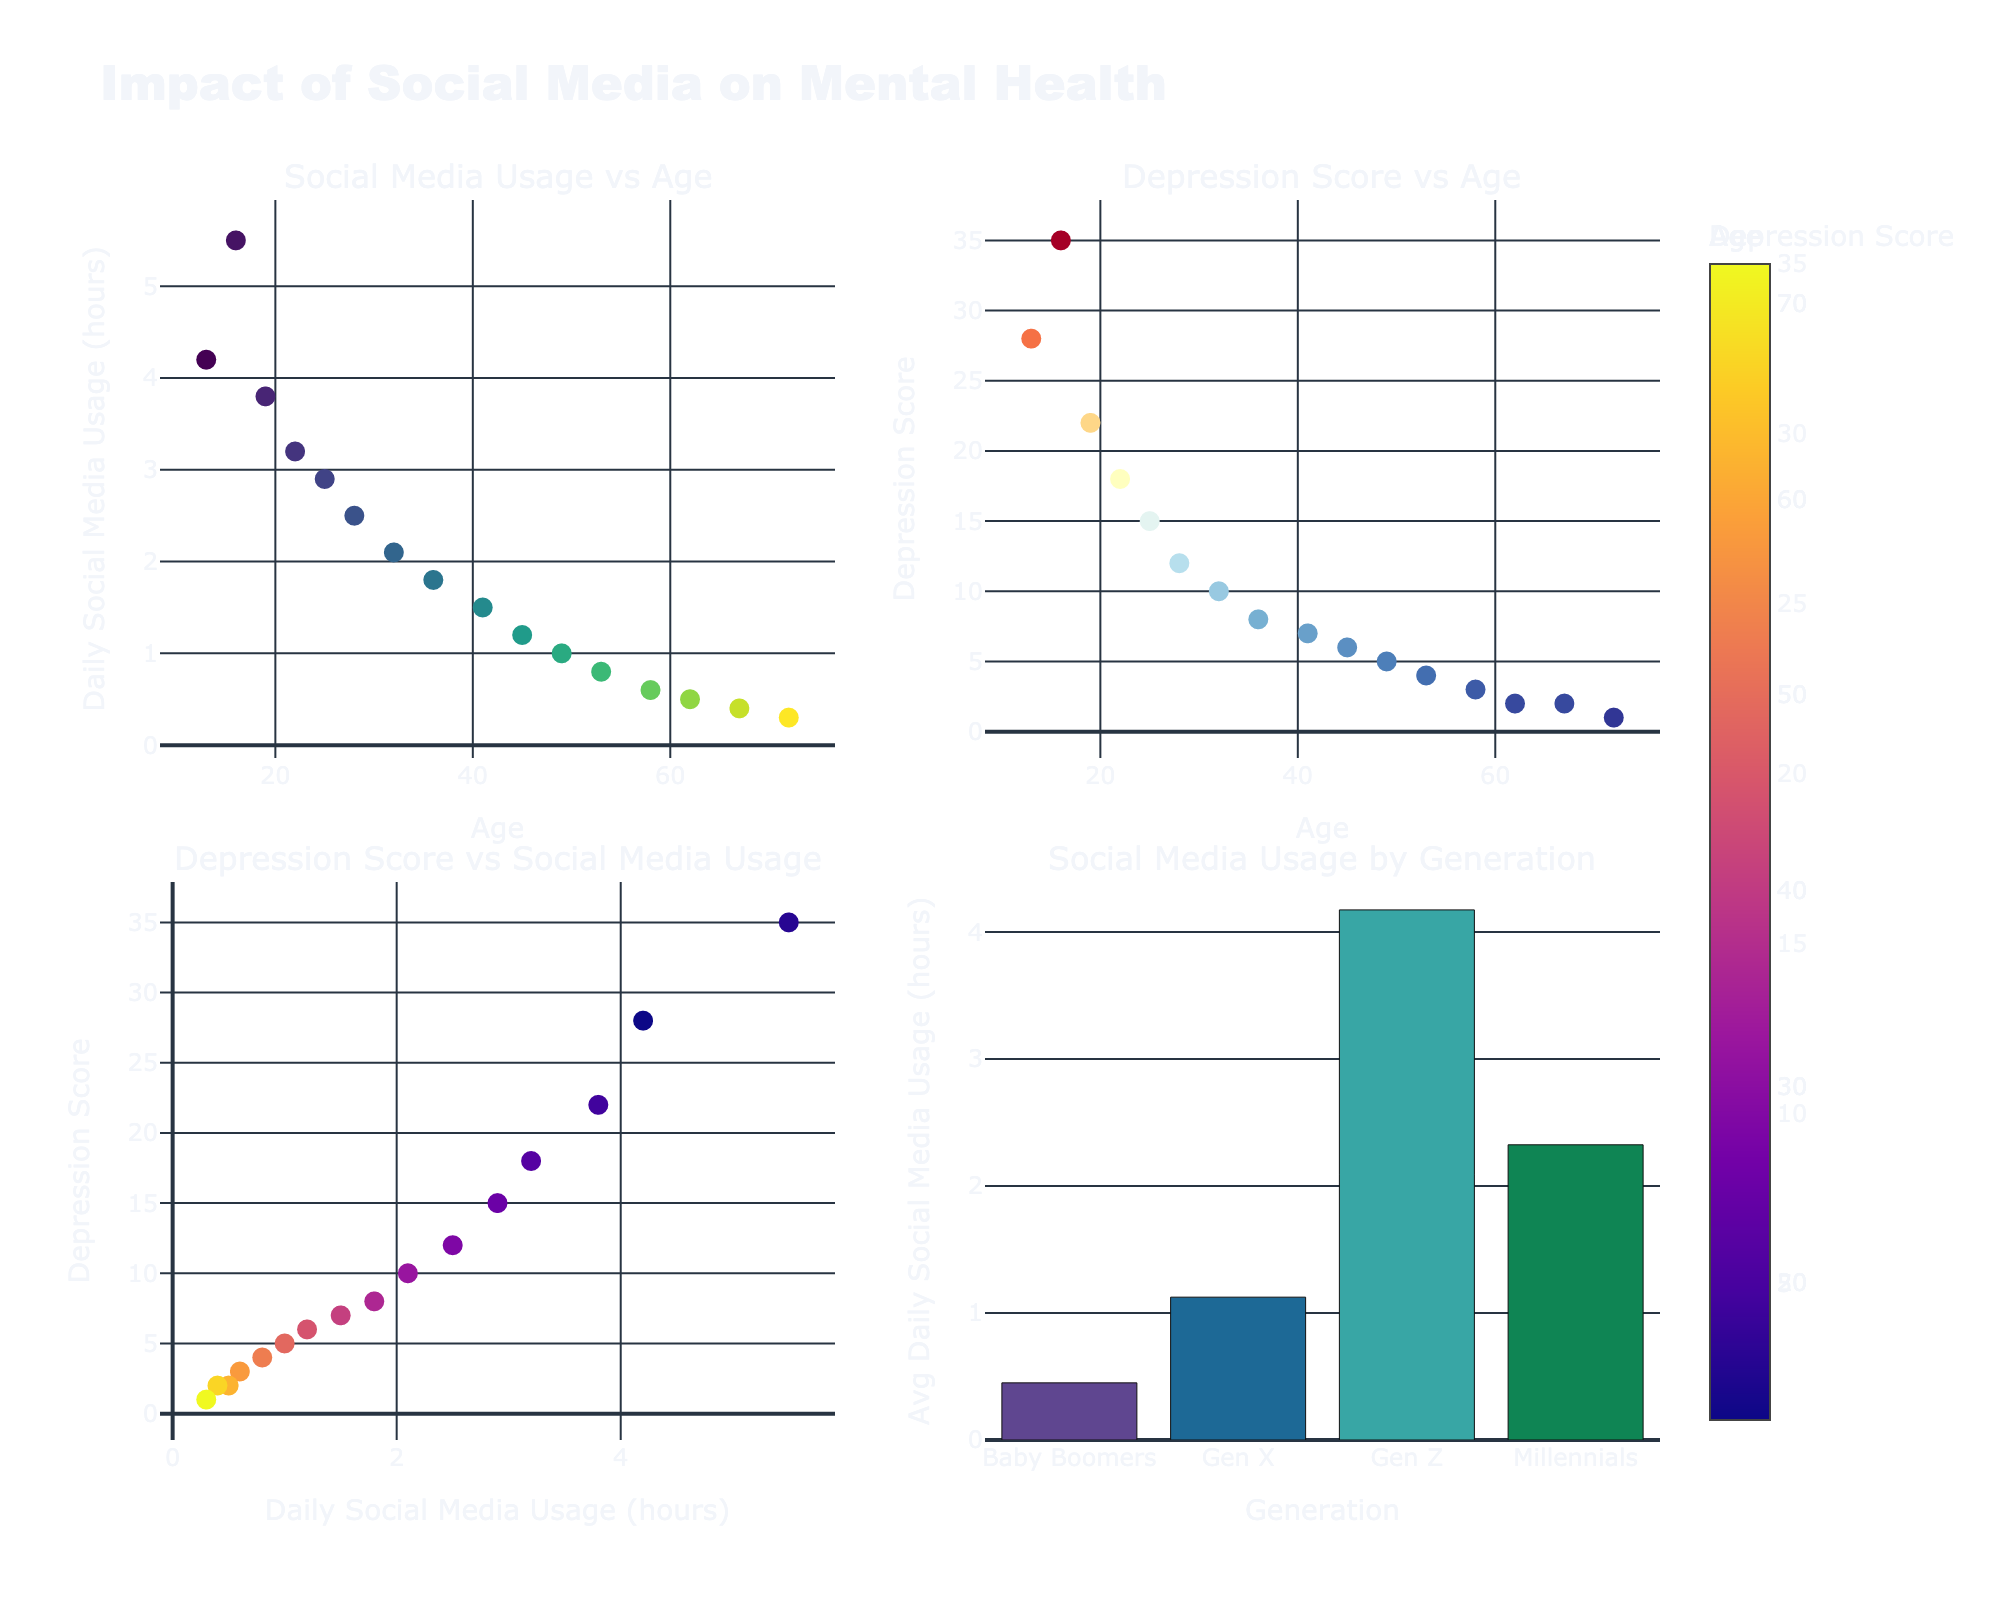What is the title of the figure plotted? The title of the figure is typically placed at the top center of the plot, which in this case is "Art Supplies Market in Liverpool."
Answer: Art Supplies Market in Liverpool How many brands are displayed in the figure? Counting the number of unique brands from the data, which are displayed as bubbles in the plot, we find there are 8 different brands.
Answer: 8 Which brand has the highest market share and what is its average price? From the bubble that appears largest and the hover information in the figure, Winsor & Newton has the highest market share of 25% and an average price of £45.
Answer: Winsor & Newton, £45 What are the axes titles of the first subplot? The X-axis title of the first subplot is "Average Price (£)" and the Y-axis title is "Market Share (%)." This can be seen below the axis lines and next to the axis lines respectively.
Answer: Average Price (£), Market Share (%) Between Daler-Rowney and Faber-Castell, which brand has a higher market share and what are their respective prices? Comparing Daler-Rowney and Faber-Castell bubbles, Daler-Rowney has a higher market share of 18% compared to Faber-Castell's 15%. Their respective prices are £38 and £30.
Answer: Daler-Rowney, £38; Faber-Castell, £30 What is the total market share of Winsor & Newton, Daler-Rowney, and Faber-Castell combined? Summing the market shares of Winsor & Newton (25%), Daler-Rowney (18%), and Faber-Castell (15%), we get 25 + 18 + 15 = 58%.
Answer: 58% Which brand has both a low market share and a high average price? By examining the bubbles with small sizes and high placement on the price axis, Royal Talens has a low market share of 5% and a high average price of £40.
Answer: Royal Talens Which subplots show bubbles representing data and what do the colors of these bubbles represent? Both subplots show bubbles, where the colors represent the market share percentage, which can be confirmed by the color bar displayed on the side of each subplot.
Answer: Both; Market Share (%) Which brands have a sales volume above 10,000 and what are their market shares? From the X-axis of the second plot, Winsor & Newton, Daler-Rowney, and Faber-Castell have sales volumes of 15,000, 12,000, and 10,000 respectively. Their market shares are 25%, 18%, and 15%.
Answer: Winsor & Newton 25%, Daler-Rowney 18%, Faber-Castell 15% What are the average prices for the two brands with the smallest sales volumes? The second subplot shows the bubbles for Royal Talens with 3,500 sales and Derwent with 5,000 sales. Their average prices are £40 and £35, respectively.
Answer: £40, £35 